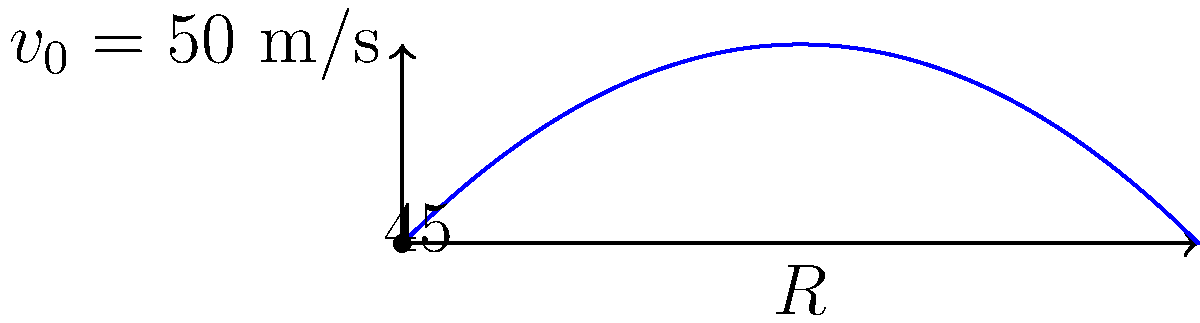A medieval trebuchet launches a projectile with an initial velocity of 50 m/s at a 45° angle. Assuming no air resistance, calculate the range (horizontal distance) the projectile will travel before hitting the ground. Use $g = 9.8$ m/s² for acceleration due to gravity. To solve this problem, we'll use the range equation for projectile motion:

1) The range equation is: $R = \frac{v_0^2 \sin(2\theta)}{g}$

2) We're given:
   - Initial velocity $v_0 = 50$ m/s
   - Launch angle $\theta = 45°$
   - Acceleration due to gravity $g = 9.8$ m/s²

3) First, we need to convert the angle to radians:
   $45° = \frac{\pi}{4}$ radians

4) Now, let's substitute these values into the range equation:
   $R = \frac{(50 \text{ m/s})^2 \sin(2 \cdot \frac{\pi}{4})}{9.8 \text{ m/s}^2}$

5) Simplify:
   $R = \frac{2500 \text{ m}^2 \cdot \sin(\frac{\pi}{2})}{9.8 \text{ m/s}^2}$

6) $\sin(\frac{\pi}{2}) = 1$, so:
   $R = \frac{2500 \text{ m}^2}{9.8 \text{ m/s}^2}$

7) Calculate:
   $R \approx 255.1$ m

Therefore, the projectile will travel approximately 255.1 meters before hitting the ground.
Answer: 255.1 m 